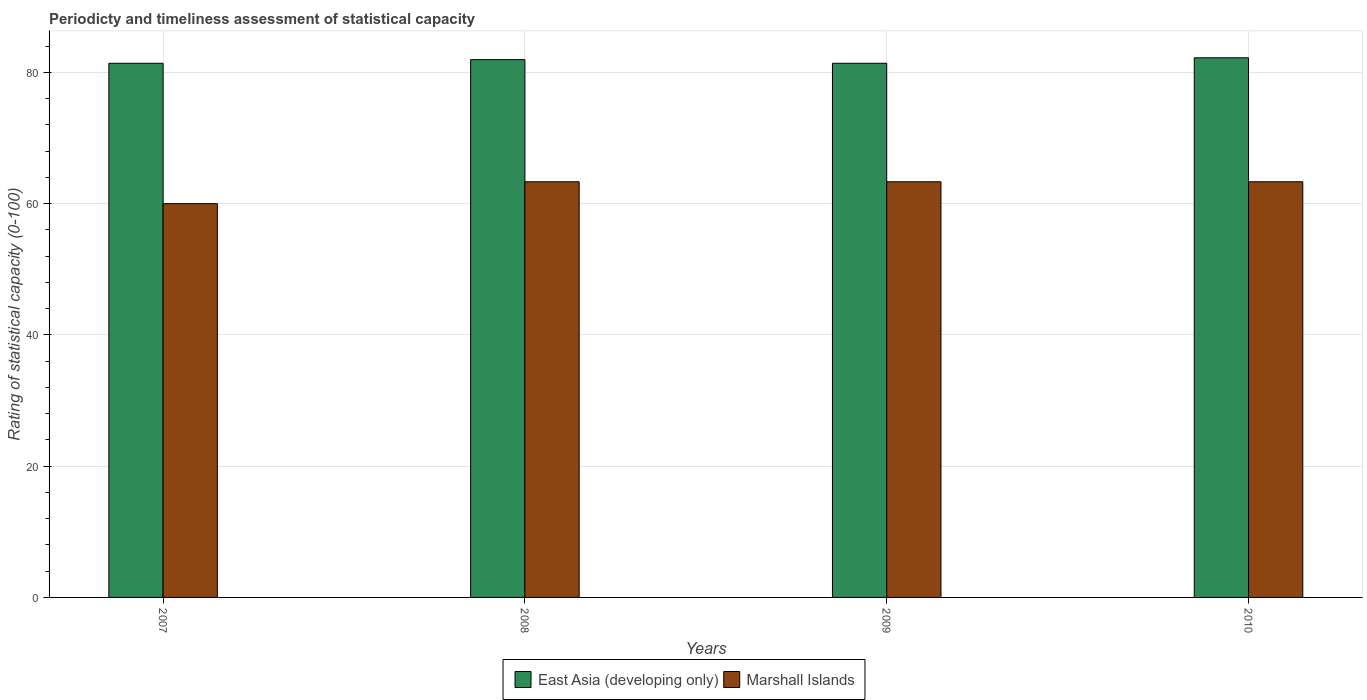How many different coloured bars are there?
Provide a short and direct response. 2. What is the label of the 4th group of bars from the left?
Your answer should be compact. 2010. In how many cases, is the number of bars for a given year not equal to the number of legend labels?
Make the answer very short. 0. What is the rating of statistical capacity in Marshall Islands in 2009?
Ensure brevity in your answer.  63.33. Across all years, what is the maximum rating of statistical capacity in East Asia (developing only)?
Provide a succinct answer. 82.22. Across all years, what is the minimum rating of statistical capacity in Marshall Islands?
Your answer should be compact. 60. What is the total rating of statistical capacity in East Asia (developing only) in the graph?
Make the answer very short. 326.94. What is the difference between the rating of statistical capacity in Marshall Islands in 2007 and that in 2008?
Offer a terse response. -3.33. What is the difference between the rating of statistical capacity in Marshall Islands in 2007 and the rating of statistical capacity in East Asia (developing only) in 2009?
Give a very brief answer. -21.39. What is the average rating of statistical capacity in Marshall Islands per year?
Your response must be concise. 62.5. In the year 2007, what is the difference between the rating of statistical capacity in Marshall Islands and rating of statistical capacity in East Asia (developing only)?
Provide a succinct answer. -21.39. What is the ratio of the rating of statistical capacity in Marshall Islands in 2008 to that in 2010?
Offer a terse response. 1. Is the rating of statistical capacity in East Asia (developing only) in 2008 less than that in 2009?
Offer a very short reply. No. Is the difference between the rating of statistical capacity in Marshall Islands in 2008 and 2009 greater than the difference between the rating of statistical capacity in East Asia (developing only) in 2008 and 2009?
Give a very brief answer. No. What is the difference between the highest and the lowest rating of statistical capacity in East Asia (developing only)?
Make the answer very short. 0.83. Is the sum of the rating of statistical capacity in Marshall Islands in 2009 and 2010 greater than the maximum rating of statistical capacity in East Asia (developing only) across all years?
Provide a succinct answer. Yes. What does the 2nd bar from the left in 2007 represents?
Offer a terse response. Marshall Islands. What does the 2nd bar from the right in 2007 represents?
Keep it short and to the point. East Asia (developing only). Are the values on the major ticks of Y-axis written in scientific E-notation?
Make the answer very short. No. Does the graph contain any zero values?
Your response must be concise. No. Does the graph contain grids?
Ensure brevity in your answer.  Yes. Where does the legend appear in the graph?
Ensure brevity in your answer.  Bottom center. What is the title of the graph?
Offer a very short reply. Periodicty and timeliness assessment of statistical capacity. What is the label or title of the Y-axis?
Offer a terse response. Rating of statistical capacity (0-100). What is the Rating of statistical capacity (0-100) of East Asia (developing only) in 2007?
Provide a succinct answer. 81.39. What is the Rating of statistical capacity (0-100) of East Asia (developing only) in 2008?
Ensure brevity in your answer.  81.94. What is the Rating of statistical capacity (0-100) of Marshall Islands in 2008?
Your answer should be very brief. 63.33. What is the Rating of statistical capacity (0-100) in East Asia (developing only) in 2009?
Offer a very short reply. 81.39. What is the Rating of statistical capacity (0-100) of Marshall Islands in 2009?
Provide a succinct answer. 63.33. What is the Rating of statistical capacity (0-100) in East Asia (developing only) in 2010?
Offer a very short reply. 82.22. What is the Rating of statistical capacity (0-100) in Marshall Islands in 2010?
Make the answer very short. 63.33. Across all years, what is the maximum Rating of statistical capacity (0-100) in East Asia (developing only)?
Give a very brief answer. 82.22. Across all years, what is the maximum Rating of statistical capacity (0-100) of Marshall Islands?
Your response must be concise. 63.33. Across all years, what is the minimum Rating of statistical capacity (0-100) of East Asia (developing only)?
Ensure brevity in your answer.  81.39. Across all years, what is the minimum Rating of statistical capacity (0-100) of Marshall Islands?
Ensure brevity in your answer.  60. What is the total Rating of statistical capacity (0-100) in East Asia (developing only) in the graph?
Your response must be concise. 326.94. What is the total Rating of statistical capacity (0-100) in Marshall Islands in the graph?
Give a very brief answer. 250. What is the difference between the Rating of statistical capacity (0-100) of East Asia (developing only) in 2007 and that in 2008?
Your response must be concise. -0.56. What is the difference between the Rating of statistical capacity (0-100) in East Asia (developing only) in 2007 and that in 2009?
Ensure brevity in your answer.  -0. What is the difference between the Rating of statistical capacity (0-100) of Marshall Islands in 2007 and that in 2010?
Your response must be concise. -3.33. What is the difference between the Rating of statistical capacity (0-100) in East Asia (developing only) in 2008 and that in 2009?
Make the answer very short. 0.56. What is the difference between the Rating of statistical capacity (0-100) in East Asia (developing only) in 2008 and that in 2010?
Keep it short and to the point. -0.28. What is the difference between the Rating of statistical capacity (0-100) of Marshall Islands in 2008 and that in 2010?
Offer a very short reply. 0. What is the difference between the Rating of statistical capacity (0-100) in East Asia (developing only) in 2009 and that in 2010?
Make the answer very short. -0.83. What is the difference between the Rating of statistical capacity (0-100) in East Asia (developing only) in 2007 and the Rating of statistical capacity (0-100) in Marshall Islands in 2008?
Provide a short and direct response. 18.06. What is the difference between the Rating of statistical capacity (0-100) in East Asia (developing only) in 2007 and the Rating of statistical capacity (0-100) in Marshall Islands in 2009?
Ensure brevity in your answer.  18.06. What is the difference between the Rating of statistical capacity (0-100) in East Asia (developing only) in 2007 and the Rating of statistical capacity (0-100) in Marshall Islands in 2010?
Keep it short and to the point. 18.06. What is the difference between the Rating of statistical capacity (0-100) of East Asia (developing only) in 2008 and the Rating of statistical capacity (0-100) of Marshall Islands in 2009?
Offer a terse response. 18.61. What is the difference between the Rating of statistical capacity (0-100) in East Asia (developing only) in 2008 and the Rating of statistical capacity (0-100) in Marshall Islands in 2010?
Offer a terse response. 18.61. What is the difference between the Rating of statistical capacity (0-100) in East Asia (developing only) in 2009 and the Rating of statistical capacity (0-100) in Marshall Islands in 2010?
Your answer should be compact. 18.06. What is the average Rating of statistical capacity (0-100) in East Asia (developing only) per year?
Your answer should be very brief. 81.74. What is the average Rating of statistical capacity (0-100) in Marshall Islands per year?
Make the answer very short. 62.5. In the year 2007, what is the difference between the Rating of statistical capacity (0-100) in East Asia (developing only) and Rating of statistical capacity (0-100) in Marshall Islands?
Your answer should be compact. 21.39. In the year 2008, what is the difference between the Rating of statistical capacity (0-100) of East Asia (developing only) and Rating of statistical capacity (0-100) of Marshall Islands?
Ensure brevity in your answer.  18.61. In the year 2009, what is the difference between the Rating of statistical capacity (0-100) in East Asia (developing only) and Rating of statistical capacity (0-100) in Marshall Islands?
Offer a terse response. 18.06. In the year 2010, what is the difference between the Rating of statistical capacity (0-100) in East Asia (developing only) and Rating of statistical capacity (0-100) in Marshall Islands?
Your response must be concise. 18.89. What is the ratio of the Rating of statistical capacity (0-100) of Marshall Islands in 2007 to that in 2008?
Your response must be concise. 0.95. What is the ratio of the Rating of statistical capacity (0-100) in East Asia (developing only) in 2007 to that in 2009?
Provide a succinct answer. 1. What is the ratio of the Rating of statistical capacity (0-100) of Marshall Islands in 2007 to that in 2009?
Offer a very short reply. 0.95. What is the ratio of the Rating of statistical capacity (0-100) of Marshall Islands in 2007 to that in 2010?
Offer a very short reply. 0.95. What is the ratio of the Rating of statistical capacity (0-100) of East Asia (developing only) in 2008 to that in 2009?
Offer a terse response. 1.01. What is the ratio of the Rating of statistical capacity (0-100) in Marshall Islands in 2008 to that in 2009?
Offer a terse response. 1. What is the ratio of the Rating of statistical capacity (0-100) in Marshall Islands in 2009 to that in 2010?
Provide a short and direct response. 1. What is the difference between the highest and the second highest Rating of statistical capacity (0-100) in East Asia (developing only)?
Provide a succinct answer. 0.28. What is the difference between the highest and the lowest Rating of statistical capacity (0-100) of East Asia (developing only)?
Provide a succinct answer. 0.83. What is the difference between the highest and the lowest Rating of statistical capacity (0-100) in Marshall Islands?
Your response must be concise. 3.33. 